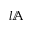<formula> <loc_0><loc_0><loc_500><loc_500>l \mathbb { A }</formula> 